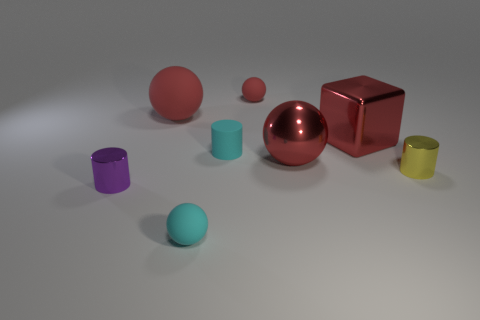Are there any other large metallic blocks of the same color as the big metal block?
Ensure brevity in your answer.  No. Are there any small things?
Ensure brevity in your answer.  Yes. There is a cyan matte thing in front of the red metal sphere; does it have the same size as the large red metallic block?
Make the answer very short. No. Are there fewer shiny objects than small yellow spheres?
Ensure brevity in your answer.  No. What is the shape of the big red rubber object behind the cyan matte object that is in front of the metal cylinder that is on the right side of the tiny red matte thing?
Keep it short and to the point. Sphere. Is there a cyan cylinder that has the same material as the large block?
Provide a short and direct response. No. There is a tiny ball that is in front of the yellow thing; is its color the same as the small sphere that is behind the small purple cylinder?
Provide a short and direct response. No. Is the number of cyan spheres that are behind the small yellow cylinder less than the number of red cylinders?
Offer a very short reply. No. How many things are matte cylinders or things to the right of the cyan rubber cylinder?
Your answer should be compact. 5. What color is the large thing that is made of the same material as the cyan cylinder?
Provide a succinct answer. Red. 